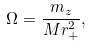Convert formula to latex. <formula><loc_0><loc_0><loc_500><loc_500>\Omega = \frac { m _ { z } } { M r _ { + } ^ { 2 } } ,</formula> 